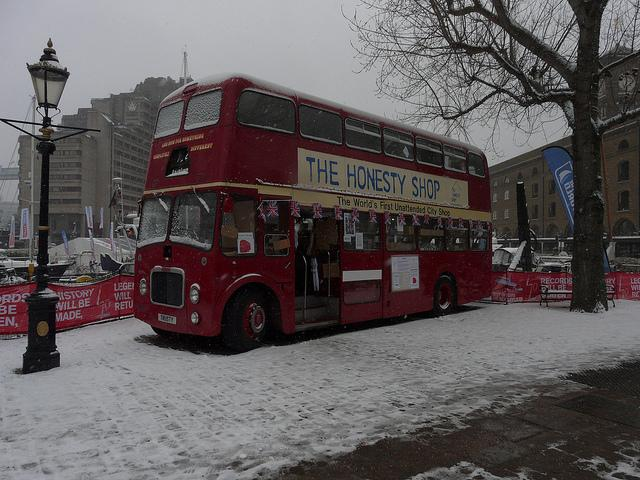Which side of the bus can people enter through? left 